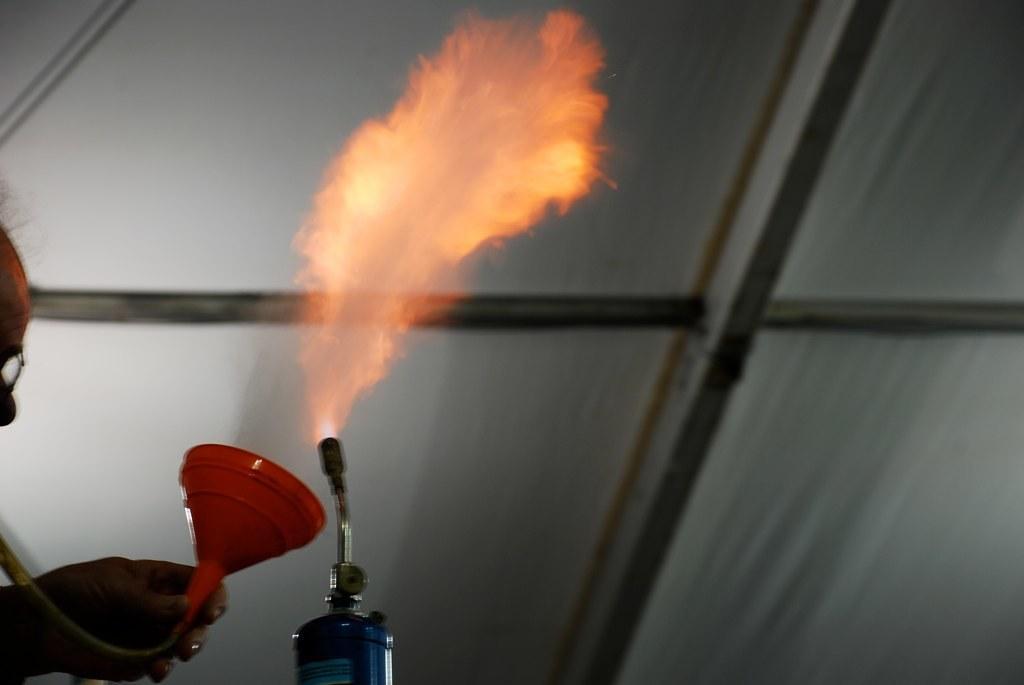In one or two sentences, can you explain what this image depicts? In this image there is a person holding red color funnel in the left side,he is also wearing spectacles. There is a fire extinguisher in the foreground. It might be shed in the background. 